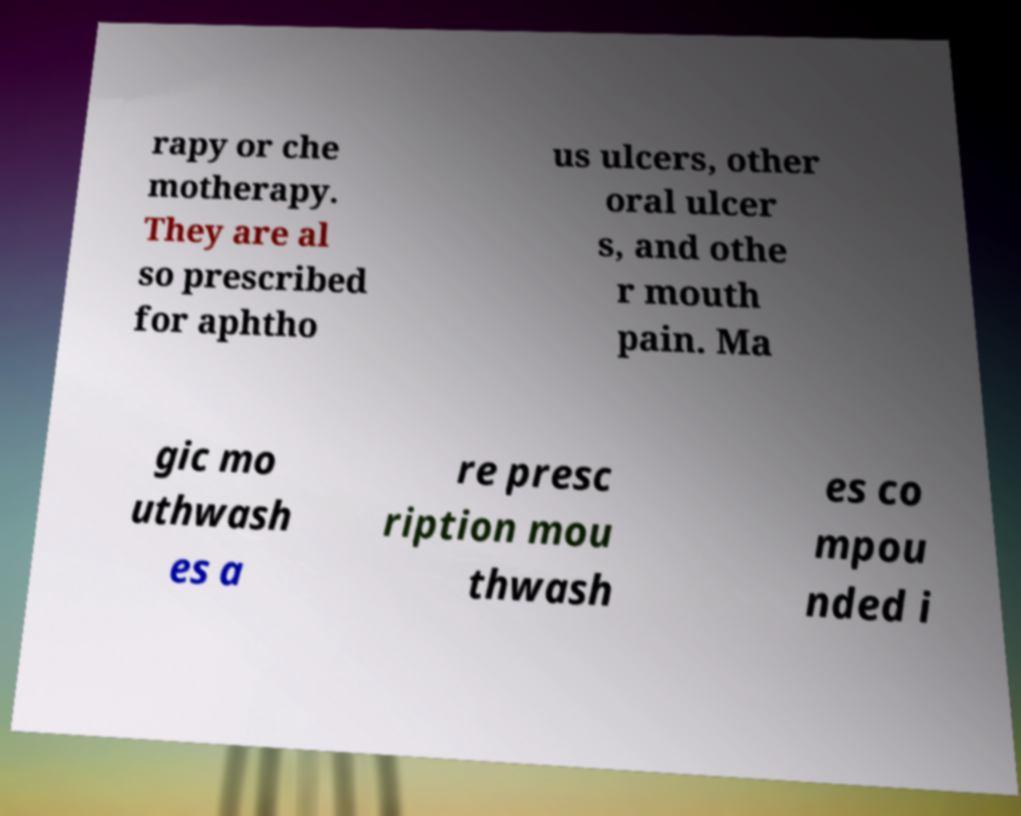There's text embedded in this image that I need extracted. Can you transcribe it verbatim? rapy or che motherapy. They are al so prescribed for aphtho us ulcers, other oral ulcer s, and othe r mouth pain. Ma gic mo uthwash es a re presc ription mou thwash es co mpou nded i 